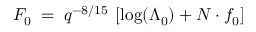Convert formula to latex. <formula><loc_0><loc_0><loc_500><loc_500>F _ { 0 } \, = \, q ^ { - 8 / 1 5 } \, \left [ \log ( \Lambda _ { 0 } ) + N \cdot f _ { 0 } \right ]</formula> 